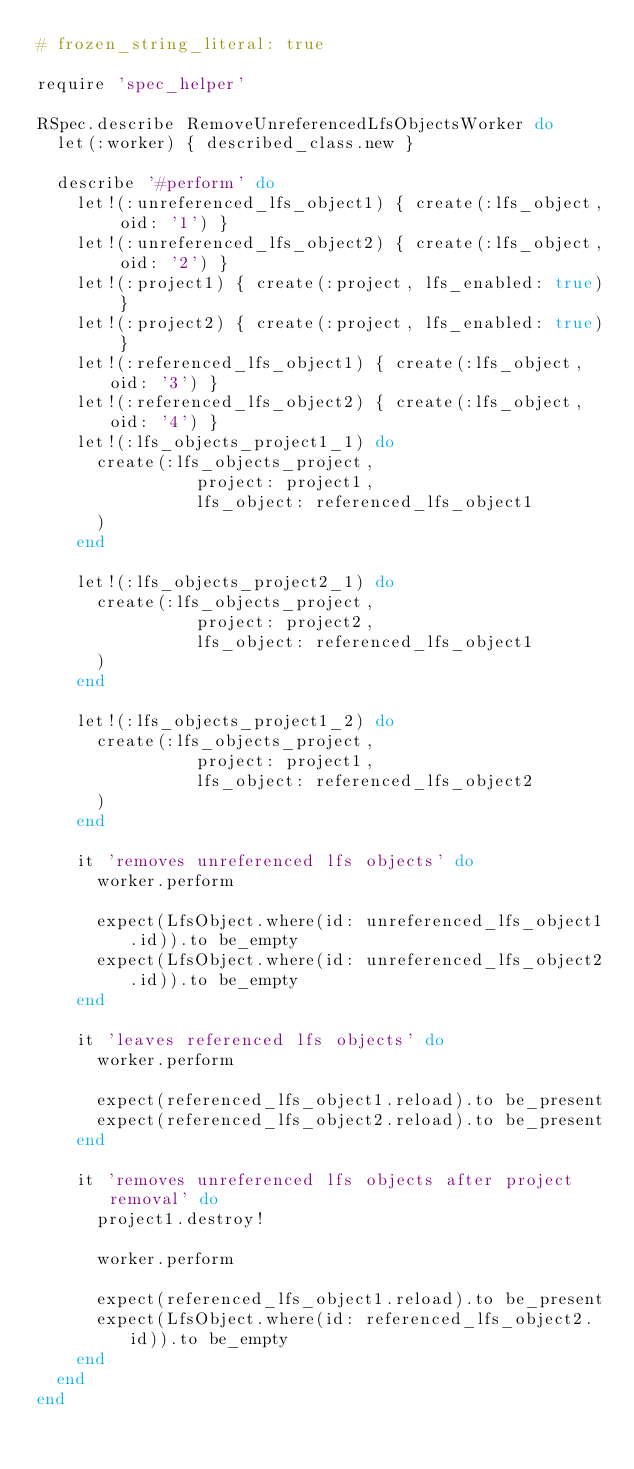Convert code to text. <code><loc_0><loc_0><loc_500><loc_500><_Ruby_># frozen_string_literal: true

require 'spec_helper'

RSpec.describe RemoveUnreferencedLfsObjectsWorker do
  let(:worker) { described_class.new }

  describe '#perform' do
    let!(:unreferenced_lfs_object1) { create(:lfs_object, oid: '1') }
    let!(:unreferenced_lfs_object2) { create(:lfs_object, oid: '2') }
    let!(:project1) { create(:project, lfs_enabled: true) }
    let!(:project2) { create(:project, lfs_enabled: true) }
    let!(:referenced_lfs_object1) { create(:lfs_object, oid: '3') }
    let!(:referenced_lfs_object2) { create(:lfs_object, oid: '4') }
    let!(:lfs_objects_project1_1) do
      create(:lfs_objects_project,
                project: project1,
                lfs_object: referenced_lfs_object1
      )
    end

    let!(:lfs_objects_project2_1) do
      create(:lfs_objects_project,
                project: project2,
                lfs_object: referenced_lfs_object1
      )
    end

    let!(:lfs_objects_project1_2) do
      create(:lfs_objects_project,
                project: project1,
                lfs_object: referenced_lfs_object2
      )
    end

    it 'removes unreferenced lfs objects' do
      worker.perform

      expect(LfsObject.where(id: unreferenced_lfs_object1.id)).to be_empty
      expect(LfsObject.where(id: unreferenced_lfs_object2.id)).to be_empty
    end

    it 'leaves referenced lfs objects' do
      worker.perform

      expect(referenced_lfs_object1.reload).to be_present
      expect(referenced_lfs_object2.reload).to be_present
    end

    it 'removes unreferenced lfs objects after project removal' do
      project1.destroy!

      worker.perform

      expect(referenced_lfs_object1.reload).to be_present
      expect(LfsObject.where(id: referenced_lfs_object2.id)).to be_empty
    end
  end
end
</code> 